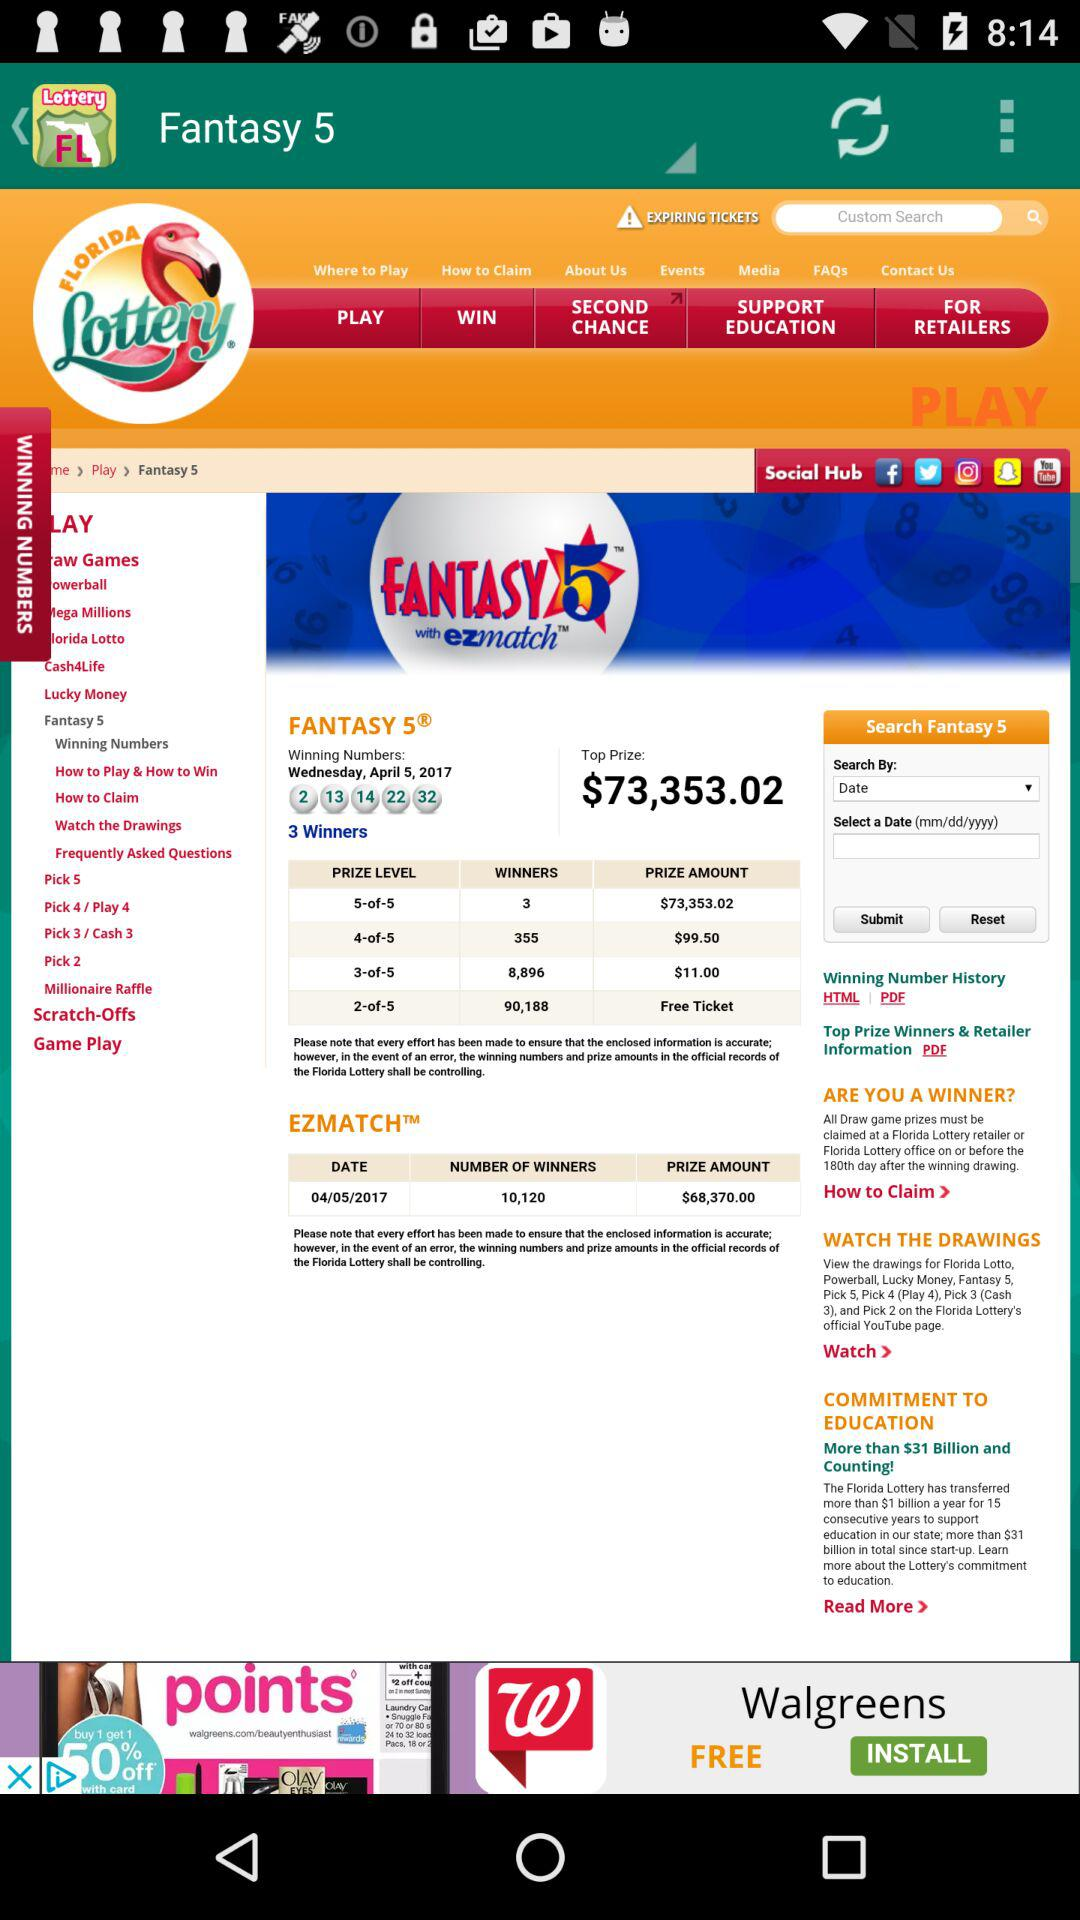What is the date for "Winning Numbers" in "FANTASY 5"? The date for "Winning Numbers" in "FANTASY 5" is Wednesday, April 5, 2017. 